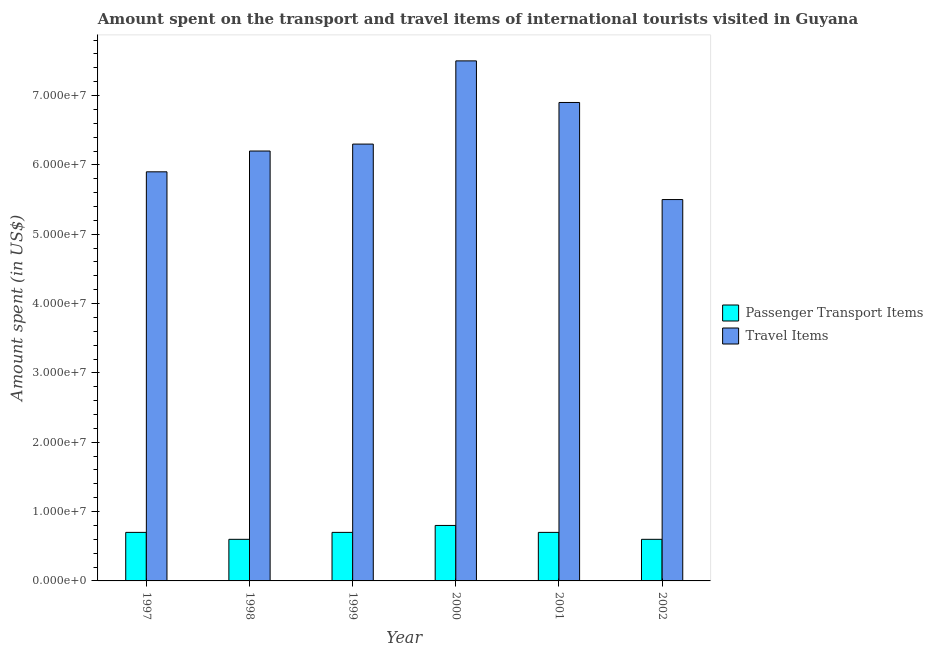How many different coloured bars are there?
Provide a succinct answer. 2. How many bars are there on the 1st tick from the left?
Provide a succinct answer. 2. How many bars are there on the 6th tick from the right?
Make the answer very short. 2. What is the label of the 5th group of bars from the left?
Keep it short and to the point. 2001. What is the amount spent on passenger transport items in 2000?
Your answer should be very brief. 8.00e+06. Across all years, what is the maximum amount spent in travel items?
Offer a terse response. 7.50e+07. Across all years, what is the minimum amount spent on passenger transport items?
Make the answer very short. 6.00e+06. In which year was the amount spent in travel items maximum?
Ensure brevity in your answer.  2000. What is the total amount spent in travel items in the graph?
Your answer should be compact. 3.83e+08. What is the difference between the amount spent on passenger transport items in 1998 and that in 2002?
Provide a succinct answer. 0. What is the difference between the amount spent on passenger transport items in 2001 and the amount spent in travel items in 2002?
Ensure brevity in your answer.  1.00e+06. What is the average amount spent in travel items per year?
Ensure brevity in your answer.  6.38e+07. What is the ratio of the amount spent on passenger transport items in 1999 to that in 2002?
Your response must be concise. 1.17. Is the amount spent in travel items in 1999 less than that in 2002?
Your response must be concise. No. Is the difference between the amount spent in travel items in 2001 and 2002 greater than the difference between the amount spent on passenger transport items in 2001 and 2002?
Provide a succinct answer. No. What is the difference between the highest and the second highest amount spent in travel items?
Your answer should be very brief. 6.00e+06. What is the difference between the highest and the lowest amount spent on passenger transport items?
Provide a short and direct response. 2.00e+06. In how many years, is the amount spent in travel items greater than the average amount spent in travel items taken over all years?
Keep it short and to the point. 2. What does the 1st bar from the left in 2000 represents?
Your response must be concise. Passenger Transport Items. What does the 2nd bar from the right in 1997 represents?
Ensure brevity in your answer.  Passenger Transport Items. How many bars are there?
Keep it short and to the point. 12. Are all the bars in the graph horizontal?
Your response must be concise. No. How many years are there in the graph?
Ensure brevity in your answer.  6. Are the values on the major ticks of Y-axis written in scientific E-notation?
Your answer should be compact. Yes. Where does the legend appear in the graph?
Provide a short and direct response. Center right. How many legend labels are there?
Offer a terse response. 2. What is the title of the graph?
Ensure brevity in your answer.  Amount spent on the transport and travel items of international tourists visited in Guyana. Does "Broad money growth" appear as one of the legend labels in the graph?
Offer a terse response. No. What is the label or title of the Y-axis?
Offer a terse response. Amount spent (in US$). What is the Amount spent (in US$) of Travel Items in 1997?
Your answer should be very brief. 5.90e+07. What is the Amount spent (in US$) in Passenger Transport Items in 1998?
Your response must be concise. 6.00e+06. What is the Amount spent (in US$) in Travel Items in 1998?
Offer a terse response. 6.20e+07. What is the Amount spent (in US$) of Passenger Transport Items in 1999?
Give a very brief answer. 7.00e+06. What is the Amount spent (in US$) in Travel Items in 1999?
Give a very brief answer. 6.30e+07. What is the Amount spent (in US$) of Travel Items in 2000?
Make the answer very short. 7.50e+07. What is the Amount spent (in US$) in Travel Items in 2001?
Offer a very short reply. 6.90e+07. What is the Amount spent (in US$) in Passenger Transport Items in 2002?
Keep it short and to the point. 6.00e+06. What is the Amount spent (in US$) in Travel Items in 2002?
Keep it short and to the point. 5.50e+07. Across all years, what is the maximum Amount spent (in US$) in Passenger Transport Items?
Your response must be concise. 8.00e+06. Across all years, what is the maximum Amount spent (in US$) in Travel Items?
Ensure brevity in your answer.  7.50e+07. Across all years, what is the minimum Amount spent (in US$) in Passenger Transport Items?
Make the answer very short. 6.00e+06. Across all years, what is the minimum Amount spent (in US$) of Travel Items?
Your answer should be very brief. 5.50e+07. What is the total Amount spent (in US$) of Passenger Transport Items in the graph?
Provide a succinct answer. 4.10e+07. What is the total Amount spent (in US$) in Travel Items in the graph?
Give a very brief answer. 3.83e+08. What is the difference between the Amount spent (in US$) in Passenger Transport Items in 1997 and that in 1998?
Give a very brief answer. 1.00e+06. What is the difference between the Amount spent (in US$) in Travel Items in 1997 and that in 1998?
Ensure brevity in your answer.  -3.00e+06. What is the difference between the Amount spent (in US$) of Passenger Transport Items in 1997 and that in 1999?
Your response must be concise. 0. What is the difference between the Amount spent (in US$) in Travel Items in 1997 and that in 1999?
Keep it short and to the point. -4.00e+06. What is the difference between the Amount spent (in US$) in Passenger Transport Items in 1997 and that in 2000?
Keep it short and to the point. -1.00e+06. What is the difference between the Amount spent (in US$) in Travel Items in 1997 and that in 2000?
Your response must be concise. -1.60e+07. What is the difference between the Amount spent (in US$) in Passenger Transport Items in 1997 and that in 2001?
Make the answer very short. 0. What is the difference between the Amount spent (in US$) in Travel Items in 1997 and that in 2001?
Offer a very short reply. -1.00e+07. What is the difference between the Amount spent (in US$) of Travel Items in 1997 and that in 2002?
Keep it short and to the point. 4.00e+06. What is the difference between the Amount spent (in US$) in Passenger Transport Items in 1998 and that in 1999?
Your answer should be compact. -1.00e+06. What is the difference between the Amount spent (in US$) in Travel Items in 1998 and that in 1999?
Keep it short and to the point. -1.00e+06. What is the difference between the Amount spent (in US$) in Passenger Transport Items in 1998 and that in 2000?
Your answer should be very brief. -2.00e+06. What is the difference between the Amount spent (in US$) of Travel Items in 1998 and that in 2000?
Provide a succinct answer. -1.30e+07. What is the difference between the Amount spent (in US$) of Travel Items in 1998 and that in 2001?
Provide a short and direct response. -7.00e+06. What is the difference between the Amount spent (in US$) of Travel Items in 1998 and that in 2002?
Your response must be concise. 7.00e+06. What is the difference between the Amount spent (in US$) in Travel Items in 1999 and that in 2000?
Your answer should be compact. -1.20e+07. What is the difference between the Amount spent (in US$) in Travel Items in 1999 and that in 2001?
Provide a succinct answer. -6.00e+06. What is the difference between the Amount spent (in US$) of Travel Items in 1999 and that in 2002?
Your answer should be compact. 8.00e+06. What is the difference between the Amount spent (in US$) of Passenger Transport Items in 2000 and that in 2001?
Give a very brief answer. 1.00e+06. What is the difference between the Amount spent (in US$) in Travel Items in 2000 and that in 2002?
Keep it short and to the point. 2.00e+07. What is the difference between the Amount spent (in US$) in Travel Items in 2001 and that in 2002?
Give a very brief answer. 1.40e+07. What is the difference between the Amount spent (in US$) in Passenger Transport Items in 1997 and the Amount spent (in US$) in Travel Items in 1998?
Ensure brevity in your answer.  -5.50e+07. What is the difference between the Amount spent (in US$) of Passenger Transport Items in 1997 and the Amount spent (in US$) of Travel Items in 1999?
Your answer should be very brief. -5.60e+07. What is the difference between the Amount spent (in US$) of Passenger Transport Items in 1997 and the Amount spent (in US$) of Travel Items in 2000?
Provide a short and direct response. -6.80e+07. What is the difference between the Amount spent (in US$) in Passenger Transport Items in 1997 and the Amount spent (in US$) in Travel Items in 2001?
Make the answer very short. -6.20e+07. What is the difference between the Amount spent (in US$) in Passenger Transport Items in 1997 and the Amount spent (in US$) in Travel Items in 2002?
Make the answer very short. -4.80e+07. What is the difference between the Amount spent (in US$) of Passenger Transport Items in 1998 and the Amount spent (in US$) of Travel Items in 1999?
Offer a terse response. -5.70e+07. What is the difference between the Amount spent (in US$) of Passenger Transport Items in 1998 and the Amount spent (in US$) of Travel Items in 2000?
Provide a short and direct response. -6.90e+07. What is the difference between the Amount spent (in US$) in Passenger Transport Items in 1998 and the Amount spent (in US$) in Travel Items in 2001?
Provide a succinct answer. -6.30e+07. What is the difference between the Amount spent (in US$) of Passenger Transport Items in 1998 and the Amount spent (in US$) of Travel Items in 2002?
Make the answer very short. -4.90e+07. What is the difference between the Amount spent (in US$) in Passenger Transport Items in 1999 and the Amount spent (in US$) in Travel Items in 2000?
Give a very brief answer. -6.80e+07. What is the difference between the Amount spent (in US$) in Passenger Transport Items in 1999 and the Amount spent (in US$) in Travel Items in 2001?
Provide a short and direct response. -6.20e+07. What is the difference between the Amount spent (in US$) of Passenger Transport Items in 1999 and the Amount spent (in US$) of Travel Items in 2002?
Offer a very short reply. -4.80e+07. What is the difference between the Amount spent (in US$) of Passenger Transport Items in 2000 and the Amount spent (in US$) of Travel Items in 2001?
Ensure brevity in your answer.  -6.10e+07. What is the difference between the Amount spent (in US$) in Passenger Transport Items in 2000 and the Amount spent (in US$) in Travel Items in 2002?
Give a very brief answer. -4.70e+07. What is the difference between the Amount spent (in US$) of Passenger Transport Items in 2001 and the Amount spent (in US$) of Travel Items in 2002?
Offer a very short reply. -4.80e+07. What is the average Amount spent (in US$) in Passenger Transport Items per year?
Your response must be concise. 6.83e+06. What is the average Amount spent (in US$) of Travel Items per year?
Ensure brevity in your answer.  6.38e+07. In the year 1997, what is the difference between the Amount spent (in US$) in Passenger Transport Items and Amount spent (in US$) in Travel Items?
Your answer should be very brief. -5.20e+07. In the year 1998, what is the difference between the Amount spent (in US$) of Passenger Transport Items and Amount spent (in US$) of Travel Items?
Keep it short and to the point. -5.60e+07. In the year 1999, what is the difference between the Amount spent (in US$) in Passenger Transport Items and Amount spent (in US$) in Travel Items?
Your answer should be very brief. -5.60e+07. In the year 2000, what is the difference between the Amount spent (in US$) in Passenger Transport Items and Amount spent (in US$) in Travel Items?
Provide a succinct answer. -6.70e+07. In the year 2001, what is the difference between the Amount spent (in US$) of Passenger Transport Items and Amount spent (in US$) of Travel Items?
Provide a succinct answer. -6.20e+07. In the year 2002, what is the difference between the Amount spent (in US$) in Passenger Transport Items and Amount spent (in US$) in Travel Items?
Your response must be concise. -4.90e+07. What is the ratio of the Amount spent (in US$) in Passenger Transport Items in 1997 to that in 1998?
Give a very brief answer. 1.17. What is the ratio of the Amount spent (in US$) in Travel Items in 1997 to that in 1998?
Provide a succinct answer. 0.95. What is the ratio of the Amount spent (in US$) of Travel Items in 1997 to that in 1999?
Offer a very short reply. 0.94. What is the ratio of the Amount spent (in US$) in Travel Items in 1997 to that in 2000?
Ensure brevity in your answer.  0.79. What is the ratio of the Amount spent (in US$) in Travel Items in 1997 to that in 2001?
Your answer should be compact. 0.86. What is the ratio of the Amount spent (in US$) in Travel Items in 1997 to that in 2002?
Keep it short and to the point. 1.07. What is the ratio of the Amount spent (in US$) in Passenger Transport Items in 1998 to that in 1999?
Offer a terse response. 0.86. What is the ratio of the Amount spent (in US$) in Travel Items in 1998 to that in 1999?
Ensure brevity in your answer.  0.98. What is the ratio of the Amount spent (in US$) in Travel Items in 1998 to that in 2000?
Your response must be concise. 0.83. What is the ratio of the Amount spent (in US$) of Travel Items in 1998 to that in 2001?
Your response must be concise. 0.9. What is the ratio of the Amount spent (in US$) in Passenger Transport Items in 1998 to that in 2002?
Ensure brevity in your answer.  1. What is the ratio of the Amount spent (in US$) in Travel Items in 1998 to that in 2002?
Provide a short and direct response. 1.13. What is the ratio of the Amount spent (in US$) of Travel Items in 1999 to that in 2000?
Offer a very short reply. 0.84. What is the ratio of the Amount spent (in US$) of Travel Items in 1999 to that in 2001?
Your answer should be compact. 0.91. What is the ratio of the Amount spent (in US$) in Passenger Transport Items in 1999 to that in 2002?
Provide a succinct answer. 1.17. What is the ratio of the Amount spent (in US$) of Travel Items in 1999 to that in 2002?
Give a very brief answer. 1.15. What is the ratio of the Amount spent (in US$) of Travel Items in 2000 to that in 2001?
Provide a succinct answer. 1.09. What is the ratio of the Amount spent (in US$) of Passenger Transport Items in 2000 to that in 2002?
Offer a very short reply. 1.33. What is the ratio of the Amount spent (in US$) of Travel Items in 2000 to that in 2002?
Provide a succinct answer. 1.36. What is the ratio of the Amount spent (in US$) of Passenger Transport Items in 2001 to that in 2002?
Offer a very short reply. 1.17. What is the ratio of the Amount spent (in US$) of Travel Items in 2001 to that in 2002?
Provide a succinct answer. 1.25. What is the difference between the highest and the second highest Amount spent (in US$) of Passenger Transport Items?
Provide a short and direct response. 1.00e+06. 